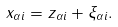Convert formula to latex. <formula><loc_0><loc_0><loc_500><loc_500>x _ { \alpha i } = z _ { \alpha i } + \xi _ { \alpha i } .</formula> 